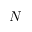Convert formula to latex. <formula><loc_0><loc_0><loc_500><loc_500>N</formula> 